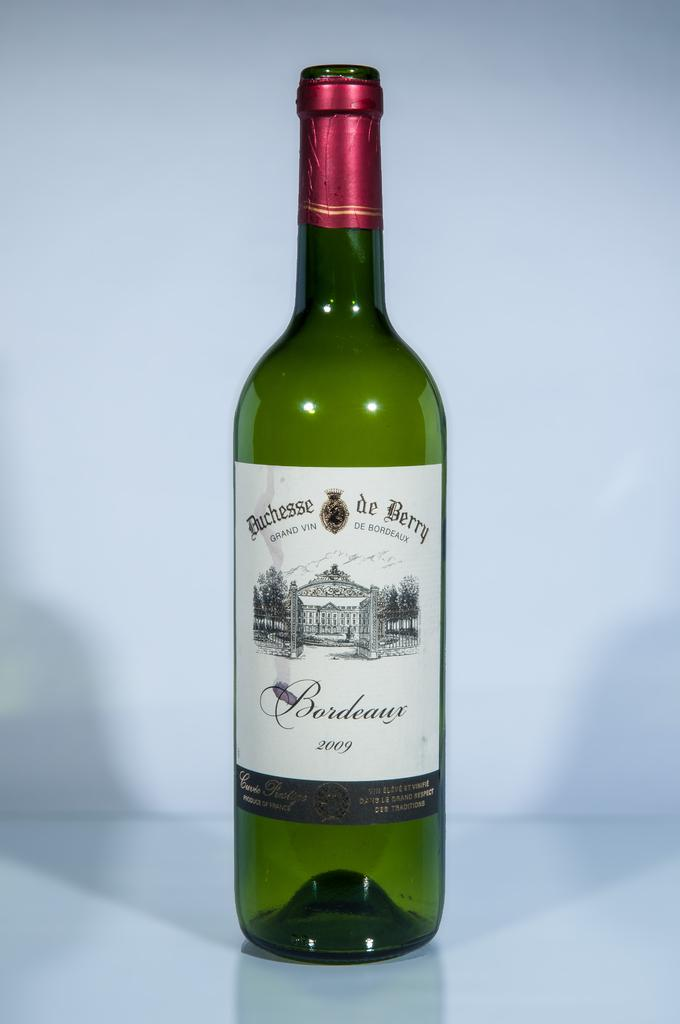<image>
Create a compact narrative representing the image presented. Green bottle of Buchessede Berry with a red cover. 